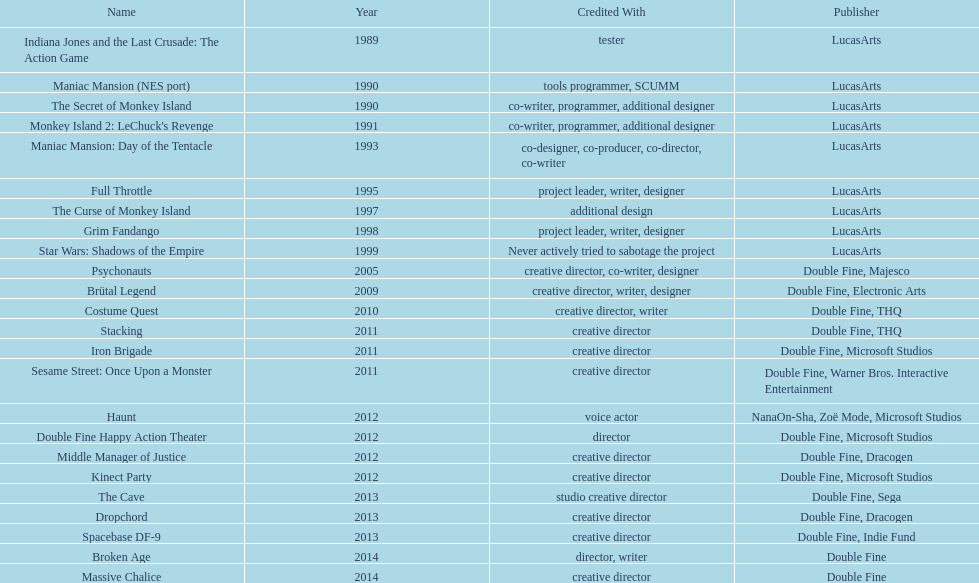Parse the full table. {'header': ['Name', 'Year', 'Credited With', 'Publisher'], 'rows': [['Indiana Jones and the Last Crusade: The Action Game', '1989', 'tester', 'LucasArts'], ['Maniac Mansion (NES port)', '1990', 'tools programmer, SCUMM', 'LucasArts'], ['The Secret of Monkey Island', '1990', 'co-writer, programmer, additional designer', 'LucasArts'], ["Monkey Island 2: LeChuck's Revenge", '1991', 'co-writer, programmer, additional designer', 'LucasArts'], ['Maniac Mansion: Day of the Tentacle', '1993', 'co-designer, co-producer, co-director, co-writer', 'LucasArts'], ['Full Throttle', '1995', 'project leader, writer, designer', 'LucasArts'], ['The Curse of Monkey Island', '1997', 'additional design', 'LucasArts'], ['Grim Fandango', '1998', 'project leader, writer, designer', 'LucasArts'], ['Star Wars: Shadows of the Empire', '1999', 'Never actively tried to sabotage the project', 'LucasArts'], ['Psychonauts', '2005', 'creative director, co-writer, designer', 'Double Fine, Majesco'], ['Brütal Legend', '2009', 'creative director, writer, designer', 'Double Fine, Electronic Arts'], ['Costume Quest', '2010', 'creative director, writer', 'Double Fine, THQ'], ['Stacking', '2011', 'creative director', 'Double Fine, THQ'], ['Iron Brigade', '2011', 'creative director', 'Double Fine, Microsoft Studios'], ['Sesame Street: Once Upon a Monster', '2011', 'creative director', 'Double Fine, Warner Bros. Interactive Entertainment'], ['Haunt', '2012', 'voice actor', 'NanaOn-Sha, Zoë Mode, Microsoft Studios'], ['Double Fine Happy Action Theater', '2012', 'director', 'Double Fine, Microsoft Studios'], ['Middle Manager of Justice', '2012', 'creative director', 'Double Fine, Dracogen'], ['Kinect Party', '2012', 'creative director', 'Double Fine, Microsoft Studios'], ['The Cave', '2013', 'studio creative director', 'Double Fine, Sega'], ['Dropchord', '2013', 'creative director', 'Double Fine, Dracogen'], ['Spacebase DF-9', '2013', 'creative director', 'Double Fine, Indie Fund'], ['Broken Age', '2014', 'director, writer', 'Double Fine'], ['Massive Chalice', '2014', 'creative director', 'Double Fine']]} Which game is credited with a creative director and warner bros. interactive entertainment as their creative director? Sesame Street: Once Upon a Monster. 